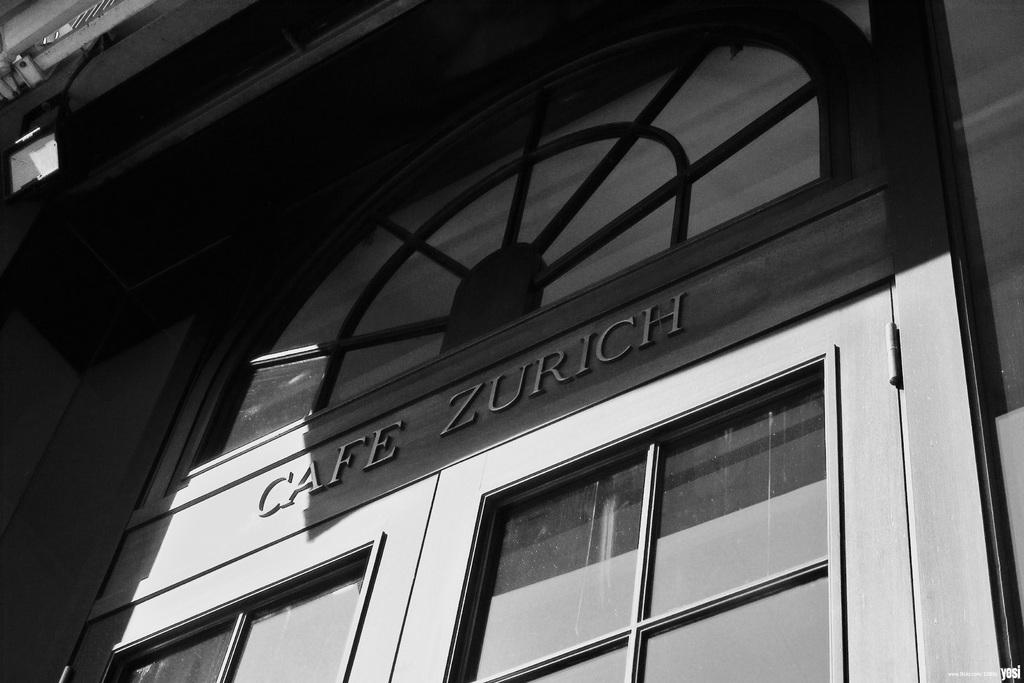What is the color scheme of the image? The image is black and white. What can be seen in the image? There is a door of a building in the image. How many feathers can be seen on the door in the image? There are no feathers present on the door in the image. What type of loss is depicted in the image? There is no loss depicted in the image; it only features a door of a building. 